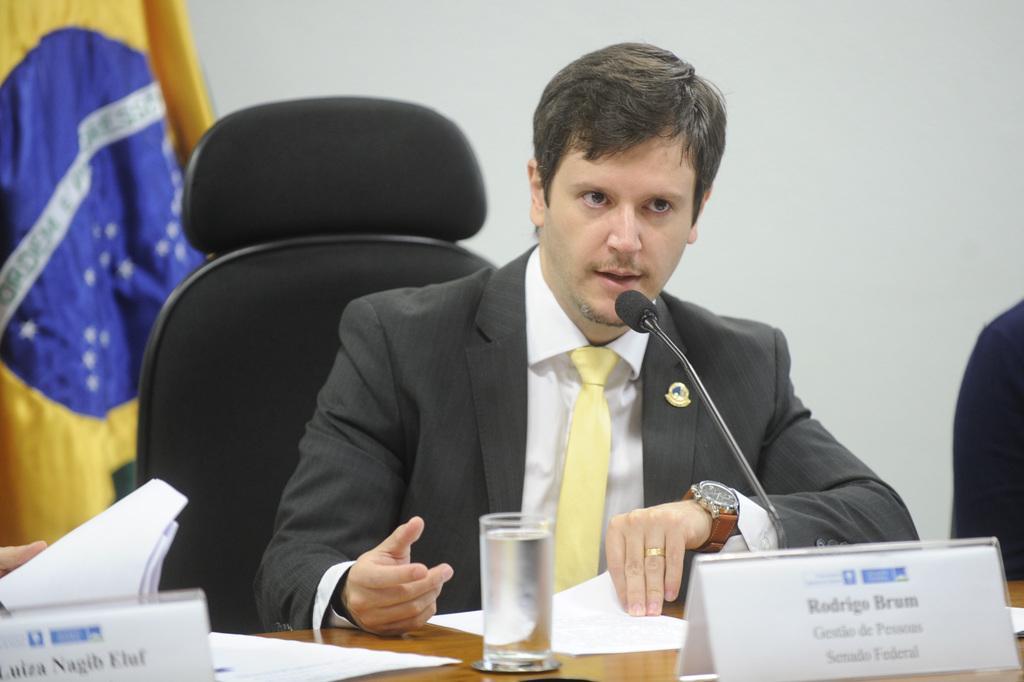In one or two sentences, can you explain what this image depicts? In the center of the image we can see a man sitting, before him there is a table and we can see a glass, papers, boards placed on the table. There is a mic. In the background there is a wall. On the left we can see a flag. 